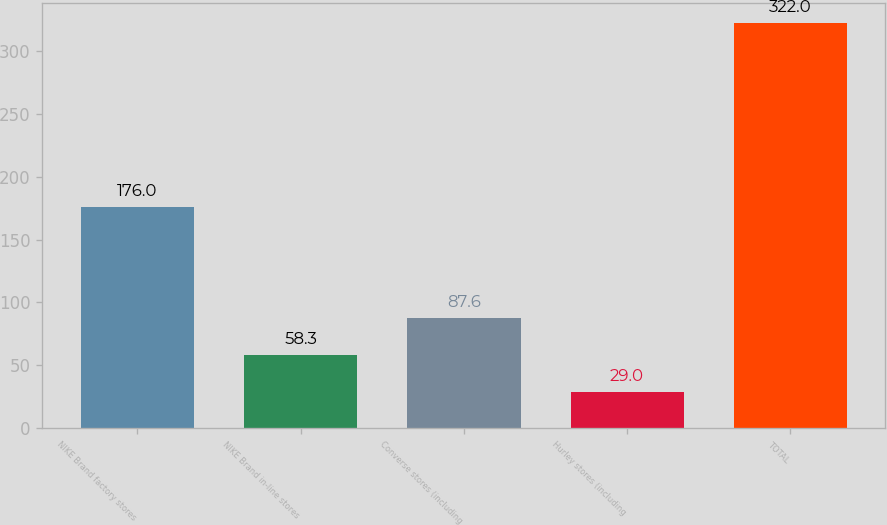Convert chart. <chart><loc_0><loc_0><loc_500><loc_500><bar_chart><fcel>NIKE Brand factory stores<fcel>NIKE Brand in-line stores<fcel>Converse stores (including<fcel>Hurley stores (including<fcel>TOTAL<nl><fcel>176<fcel>58.3<fcel>87.6<fcel>29<fcel>322<nl></chart> 